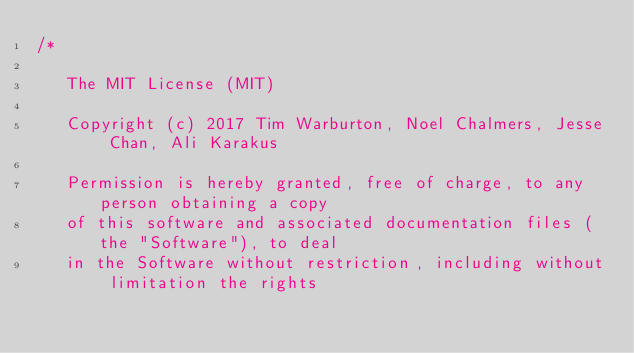Convert code to text. <code><loc_0><loc_0><loc_500><loc_500><_C++_>/*

   The MIT License (MIT)

   Copyright (c) 2017 Tim Warburton, Noel Chalmers, Jesse Chan, Ali Karakus

   Permission is hereby granted, free of charge, to any person obtaining a copy
   of this software and associated documentation files (the "Software"), to deal
   in the Software without restriction, including without limitation the rights</code> 